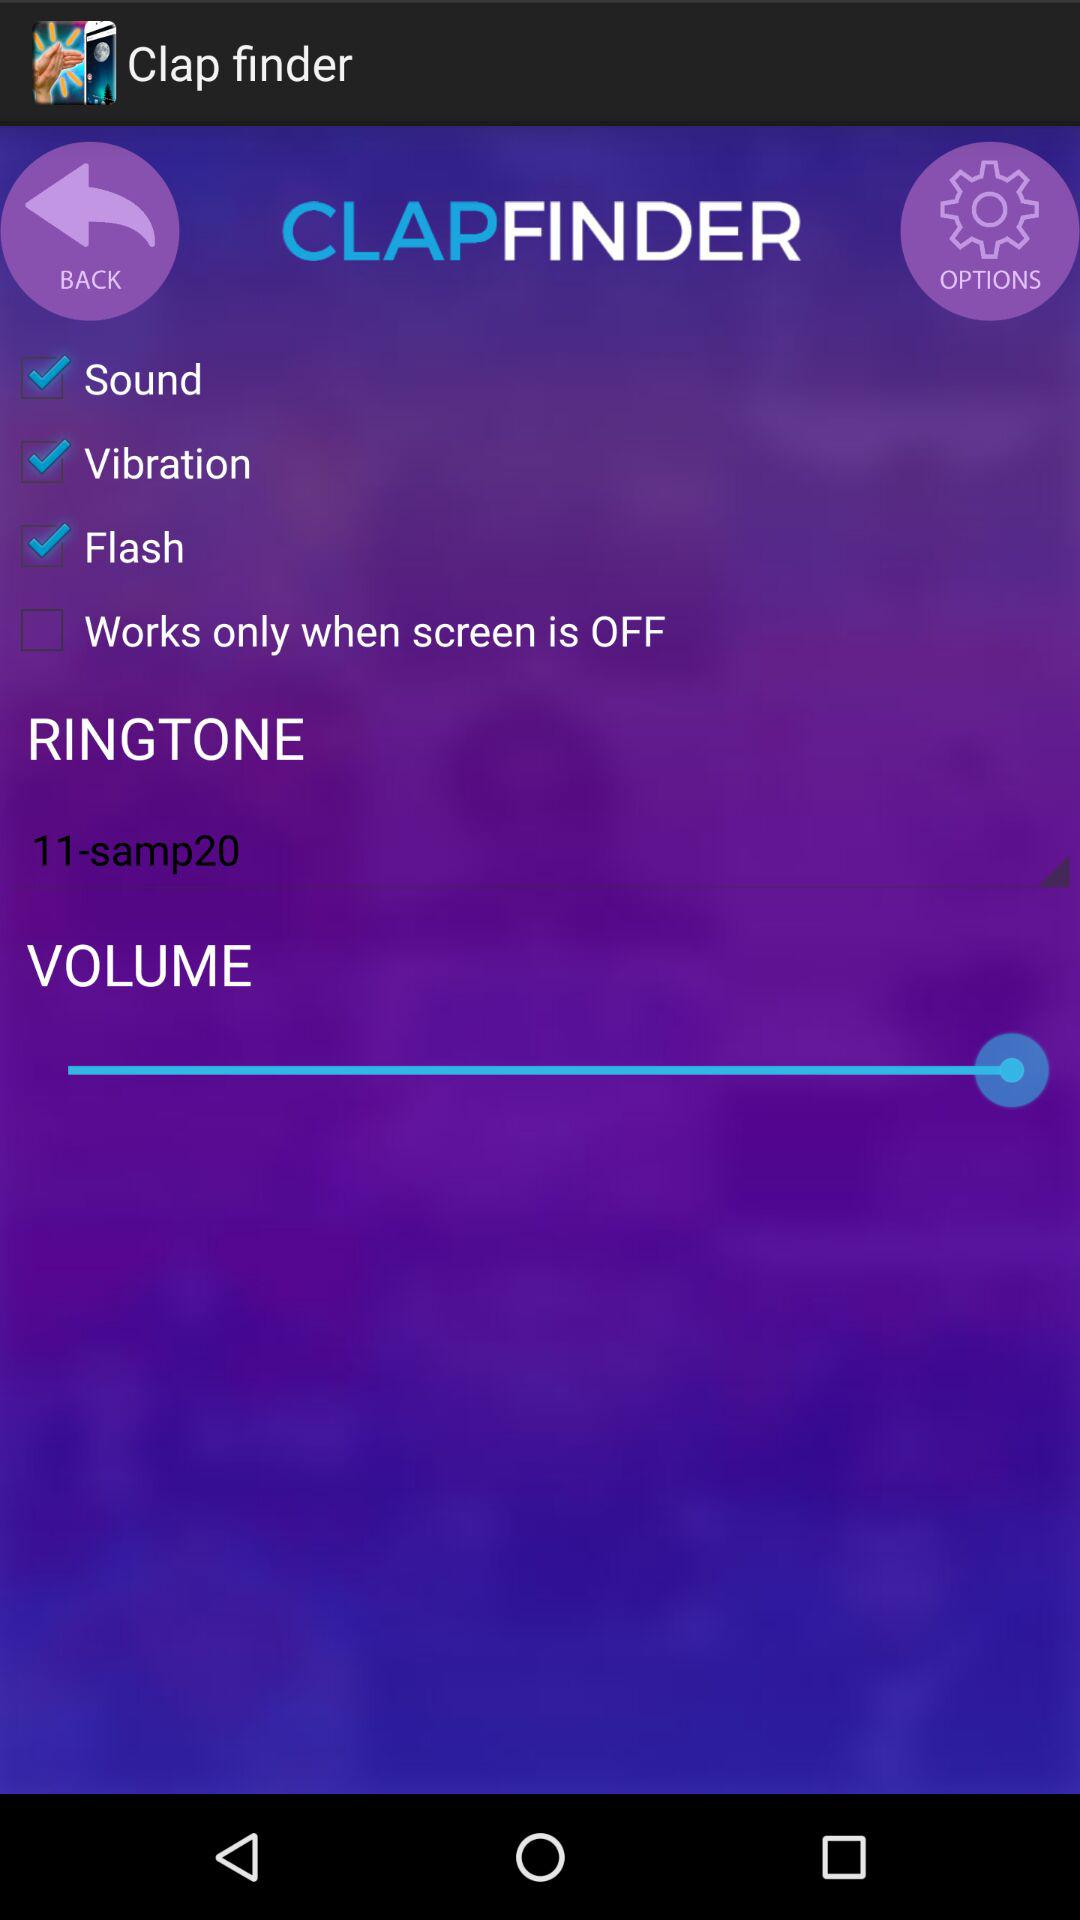What is the status of "Sound"? The status of "Sound" is "on". 